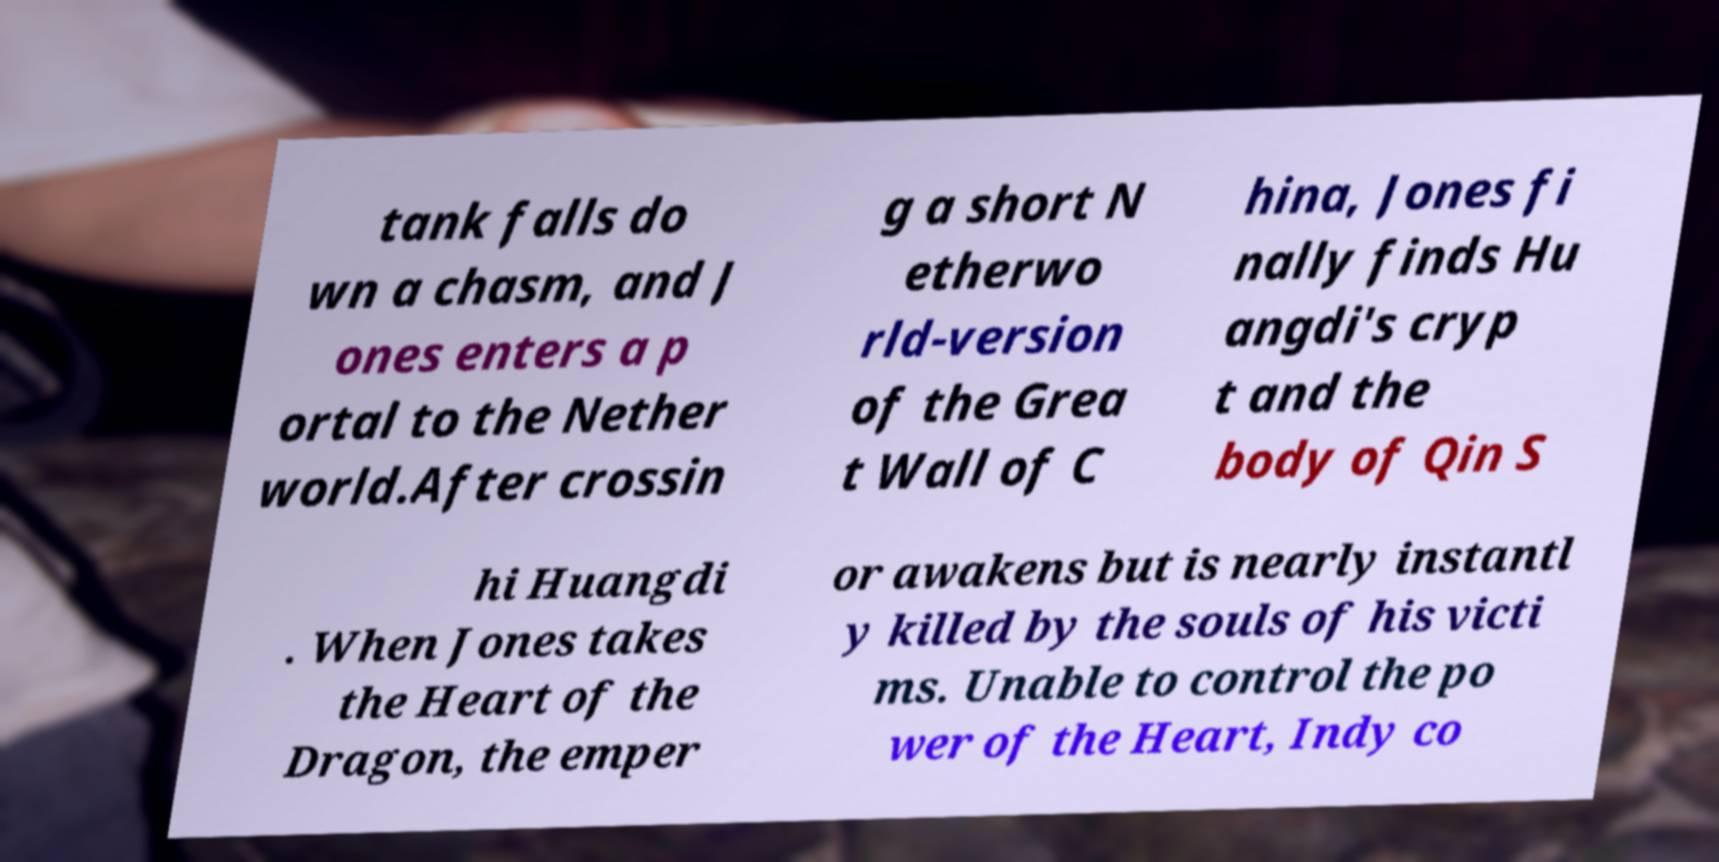There's text embedded in this image that I need extracted. Can you transcribe it verbatim? tank falls do wn a chasm, and J ones enters a p ortal to the Nether world.After crossin g a short N etherwo rld-version of the Grea t Wall of C hina, Jones fi nally finds Hu angdi's cryp t and the body of Qin S hi Huangdi . When Jones takes the Heart of the Dragon, the emper or awakens but is nearly instantl y killed by the souls of his victi ms. Unable to control the po wer of the Heart, Indy co 